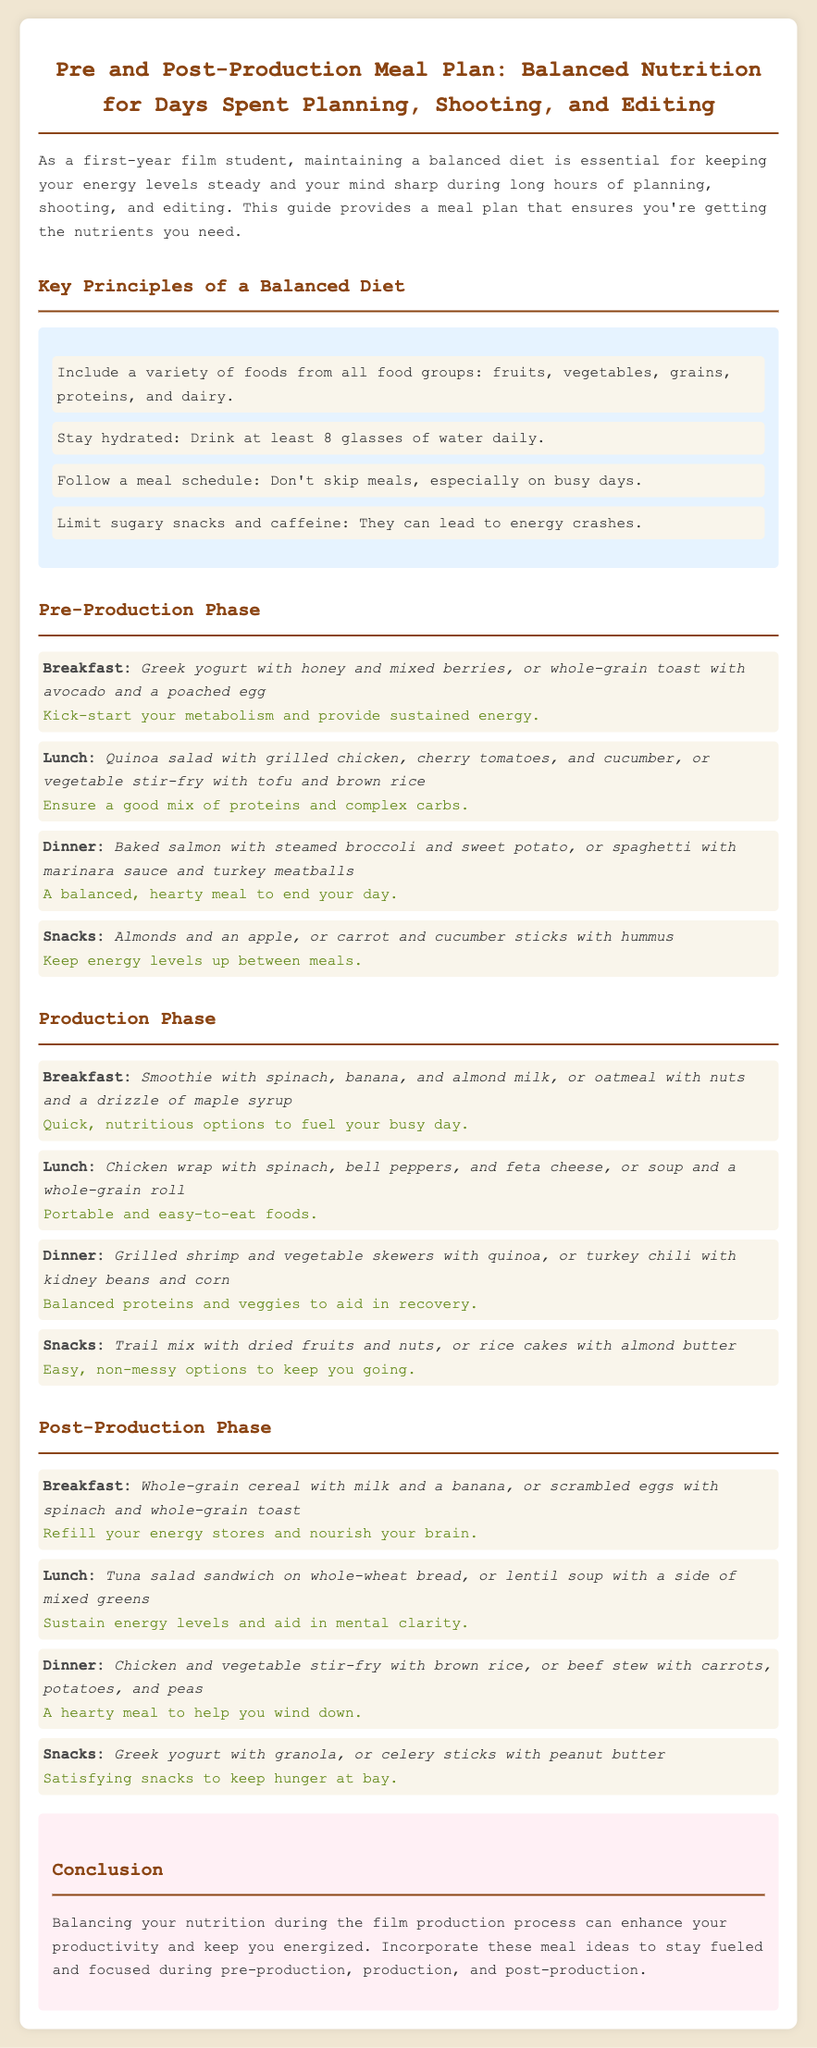What are the key principles of a balanced diet? Key principles are listed under a specific section, which includes including a variety of foods, staying hydrated, following a meal schedule, and limiting sugary snacks.
Answer: Variety of foods, hydration, meal schedule, limit sugar How often should you drink water? The document specifies a hydration recommendation stating "Drink at least 8 glasses of water daily."
Answer: 8 glasses What is a suggested breakfast option for the Production Phase? Breakfast options are provided for each phase along with their nutritional focus. An example for the Production Phase breakfast is given as a smoothie with spinach, banana, and almond milk.
Answer: Smoothie with spinach, banana, and almond milk What meal is recommended to aid recovery during the Production Phase? The dinner options in the Production Phase focus on recovery, one of which is grilled shrimp and vegetable skewers with quinoa.
Answer: Grilled shrimp and vegetable skewers with quinoa What type of snacks are suggested in the Pre-Production Phase? Snack options in the Pre-Production Phase highlight foods meant to keep energy levels up, including almonds and an apple.
Answer: Almonds and an apple Which meal in the Post-Production Phase is meant to help you wind down? The document provides dinner suggestions that aid in winding down, highlighting chicken and vegetable stir-fry with brown rice.
Answer: Chicken and vegetable stir-fry with brown rice What is a quick breakfast idea for the Pre-Production Phase? The first meal of the day in the Pre-Production phase offers quick breakfast ideas, with one option being Greek yogurt with honey and mixed berries.
Answer: Greek yogurt with honey and mixed berries How should meals be scheduled according to the meal plan? A guideline in the document emphasizes not skipping meals, particularly on busy days.
Answer: Don't skip meals 